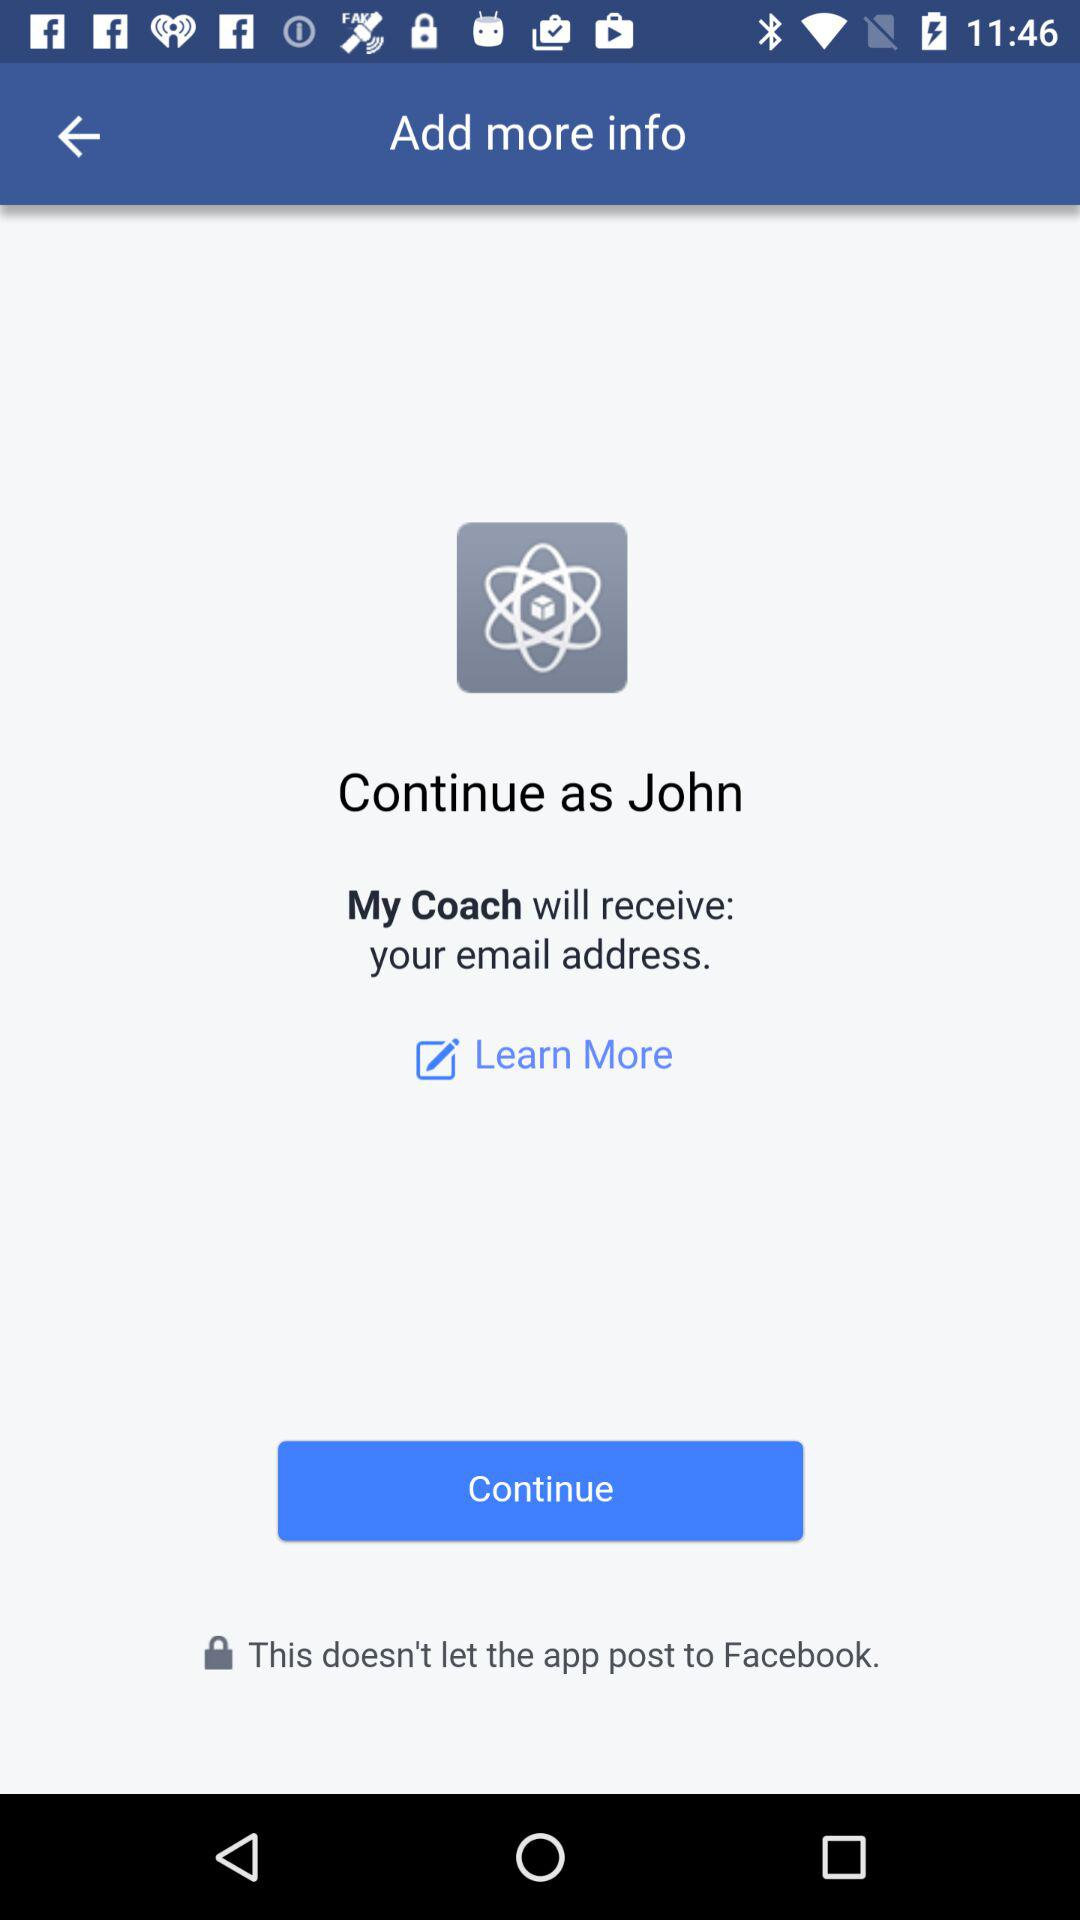What application is asking for a login? The application that is asking for a login is "My Coach". 